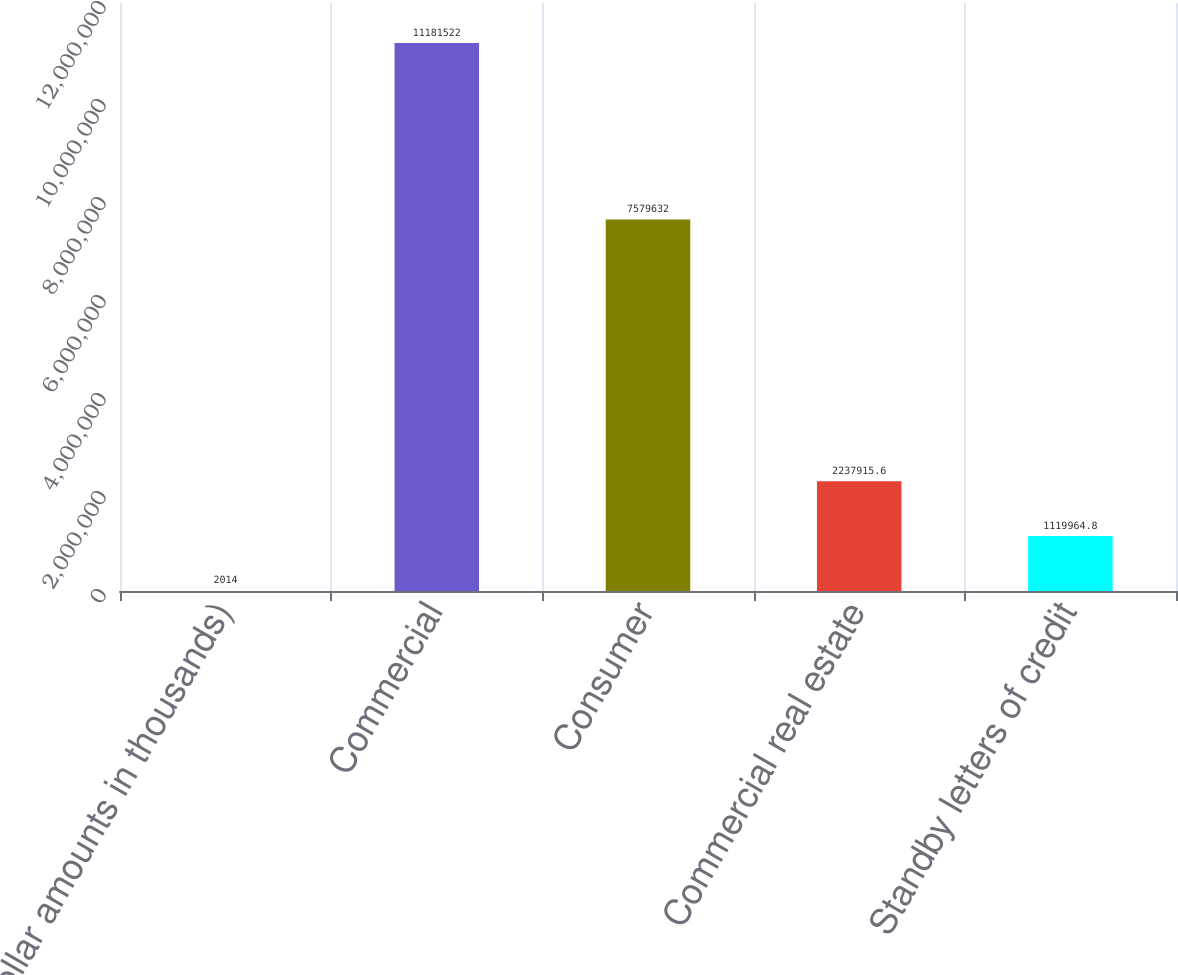Convert chart. <chart><loc_0><loc_0><loc_500><loc_500><bar_chart><fcel>(dollar amounts in thousands)<fcel>Commercial<fcel>Consumer<fcel>Commercial real estate<fcel>Standby letters of credit<nl><fcel>2014<fcel>1.11815e+07<fcel>7.57963e+06<fcel>2.23792e+06<fcel>1.11996e+06<nl></chart> 